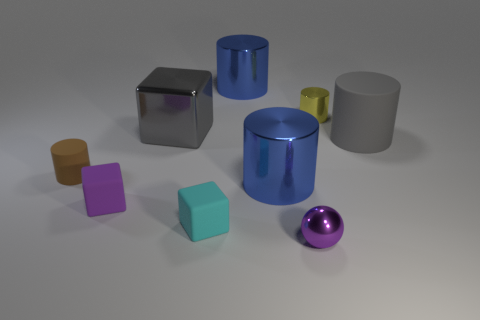What number of small things are to the right of the large cylinder behind the small cylinder behind the tiny brown thing?
Offer a very short reply. 2. Is the number of big blue metal balls less than the number of blue shiny things?
Provide a short and direct response. Yes. Does the matte thing that is on the left side of the purple rubber object have the same shape as the small thing that is behind the small brown object?
Your answer should be compact. Yes. The big block is what color?
Provide a short and direct response. Gray. How many rubber things are either big gray objects or cyan things?
Give a very brief answer. 2. What is the color of the other tiny matte object that is the same shape as the purple matte object?
Offer a terse response. Cyan. Is there a rubber block?
Offer a very short reply. Yes. Are the gray thing that is on the left side of the sphere and the purple sphere on the left side of the yellow thing made of the same material?
Provide a short and direct response. Yes. What is the shape of the big thing that is the same color as the large cube?
Ensure brevity in your answer.  Cylinder. How many objects are large blue metallic objects behind the small brown matte cylinder or small things that are to the left of the small purple metal object?
Your response must be concise. 4. 